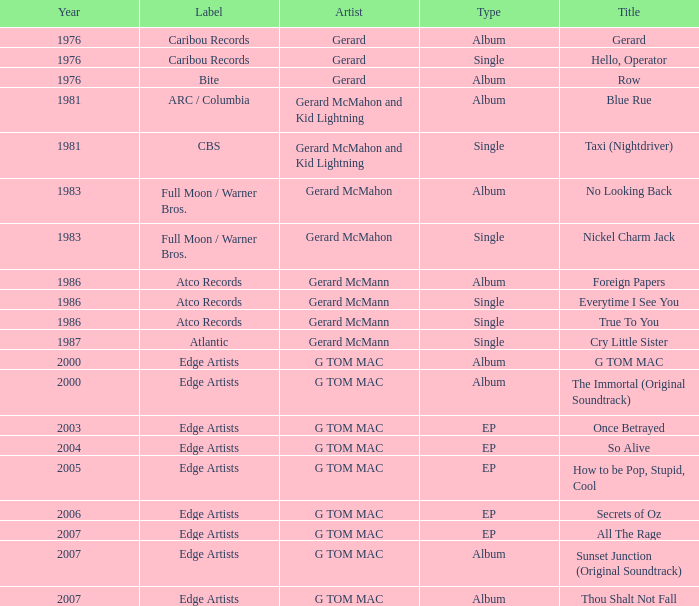Which Title has a Type of ep and a Year larger than 2003? So Alive, How to be Pop, Stupid, Cool, Secrets of Oz, All The Rage. 